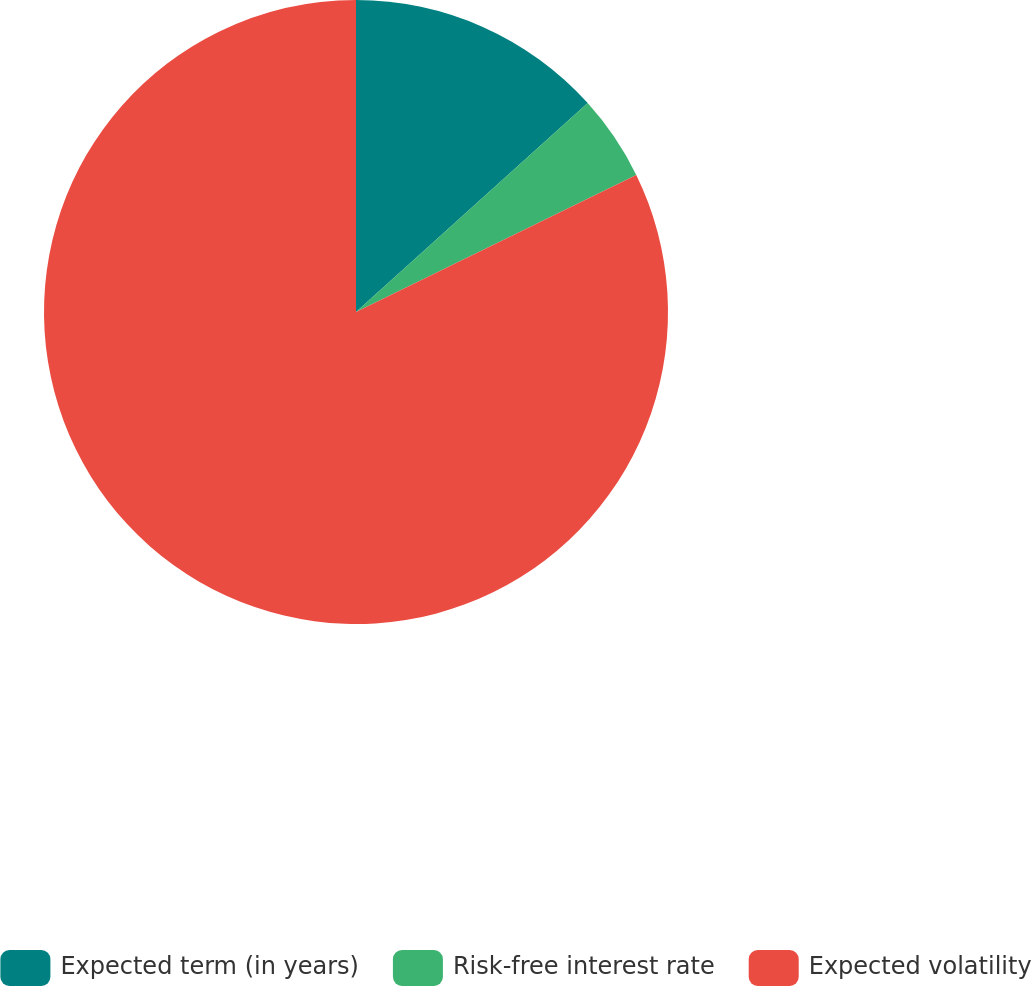Convert chart to OTSL. <chart><loc_0><loc_0><loc_500><loc_500><pie_chart><fcel>Expected term (in years)<fcel>Risk-free interest rate<fcel>Expected volatility<nl><fcel>13.32%<fcel>4.44%<fcel>82.24%<nl></chart> 